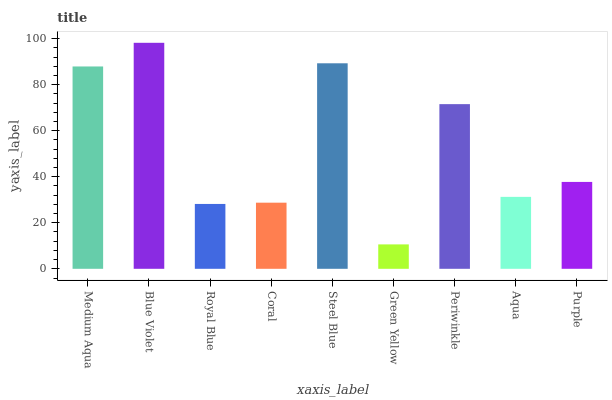Is Green Yellow the minimum?
Answer yes or no. Yes. Is Blue Violet the maximum?
Answer yes or no. Yes. Is Royal Blue the minimum?
Answer yes or no. No. Is Royal Blue the maximum?
Answer yes or no. No. Is Blue Violet greater than Royal Blue?
Answer yes or no. Yes. Is Royal Blue less than Blue Violet?
Answer yes or no. Yes. Is Royal Blue greater than Blue Violet?
Answer yes or no. No. Is Blue Violet less than Royal Blue?
Answer yes or no. No. Is Purple the high median?
Answer yes or no. Yes. Is Purple the low median?
Answer yes or no. Yes. Is Blue Violet the high median?
Answer yes or no. No. Is Green Yellow the low median?
Answer yes or no. No. 